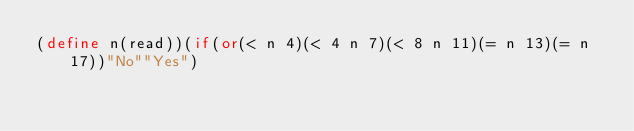<code> <loc_0><loc_0><loc_500><loc_500><_Scheme_>(define n(read))(if(or(< n 4)(< 4 n 7)(< 8 n 11)(= n 13)(= n 17))"No""Yes")</code> 